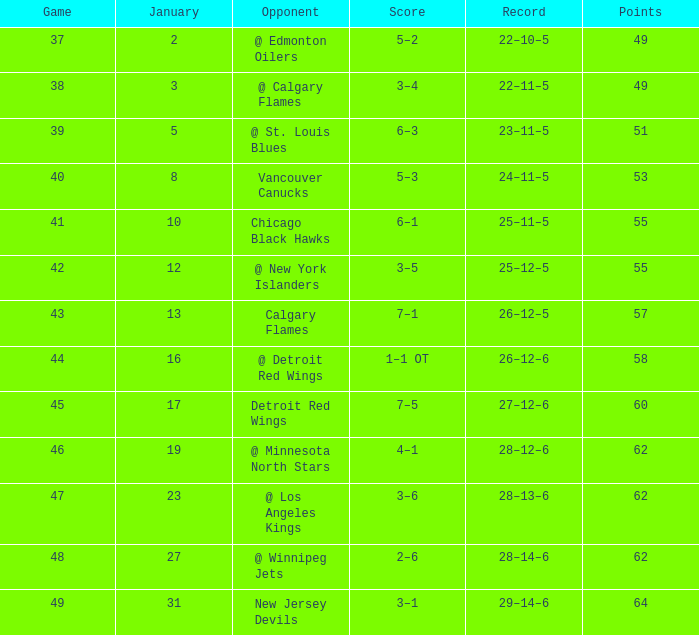On which points is the score 4-1? 62.0. 